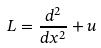Convert formula to latex. <formula><loc_0><loc_0><loc_500><loc_500>L = \frac { d ^ { 2 } } { d x ^ { 2 } } + u</formula> 